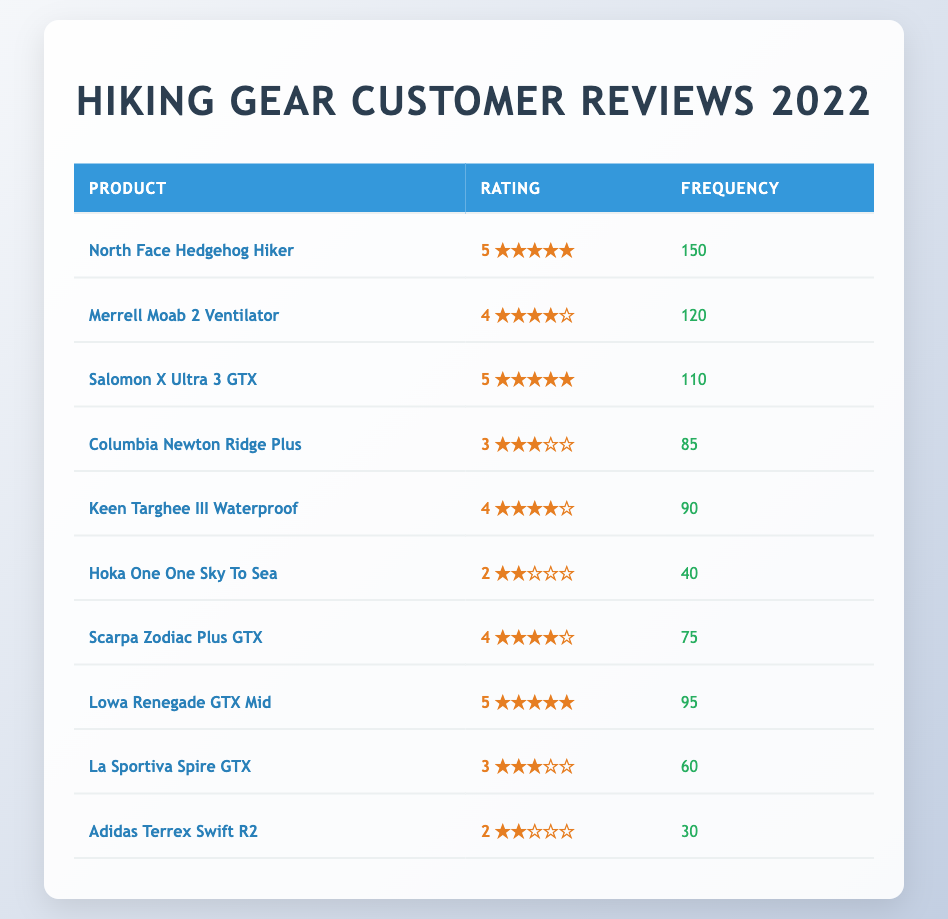What is the product with the highest rating? In the table, the ratings are listed along with the products. The product with the highest rating of 5 is the North Face Hedgehog Hiker, which has 150 reviews.
Answer: North Face Hedgehog Hiker How many products received a rating of 4? By reviewing the table, I see there are three products with a rating of 4: Merrell Moab 2 Ventilator, Keen Targhee III Waterproof, and Scarpa Zodiac Plus GTX.
Answer: 3 What is the total frequency of reviews for all products rated 5? To find the total frequency for products rated 5, I add the frequencies for North Face Hedgehog Hiker (150), Salomon X Ultra 3 GTX (110), and Lowa Renegade GTX Mid (95). This gives: 150 + 110 + 95 = 355.
Answer: 355 Is there a product with a frequency of reviews less than 40? Looking through the table, I find that the product Adidas Terrex Swift R2 has a frequency of 30, which is less than 40.
Answer: Yes What percentage of total reviews belong to the product with the lowest frequency? The product with the lowest frequency is Adidas Terrex Swift R2 with 30 reviews. First, I find the total frequency of all products, which is 150 + 120 + 110 + 85 + 90 + 40 + 75 + 95 + 60 + 30 = 1050. Then I calculate the percentage: (30/1050) * 100 = 2.86%.
Answer: 2.86% How does the frequency of reviews for products rated 3 compare to the frequency for products rated 4? There are two products rated 3: Columbia Newton Ridge Plus (85) and La Sportiva Spire GTX (60), giving a total of 145. There are three products rated 4: Merrell Moab 2 Ventilator (120), Keen Targhee III Waterproof (90), and Scarpa Zodiac Plus GTX (75), giving a total of 285. Comparing the totals, 145 for rating 3 is less than 285 for rating 4.
Answer: Frequency for rating 3 is less than for rating 4 What is the average rating for all products? To find the average, I first multiply each rating by its frequency: (5*150 + 4*120 + 5*110 + 3*85 + 4*90 + 2*40 + 4*75 + 5*95 + 3*60 + 2*30) and sum those values. Then divide by the total frequency of reviews (which is 1050): total_rating_sum = (750 + 480 + 550 + 255 + 360 + 80 + 300 + 475 + 180 + 60) = 3070. So, average rating = 3070/1050 ≈ 2.93.
Answer: 2.93 Which product has the second-highest frequency of reviews? The products are listed in order of their frequency. The highest frequency is North Face Hedgehog Hiker (150), followed by Merrell Moab 2 Ventilator (120) as the second-highest.
Answer: Merrell Moab 2 Ventilator 